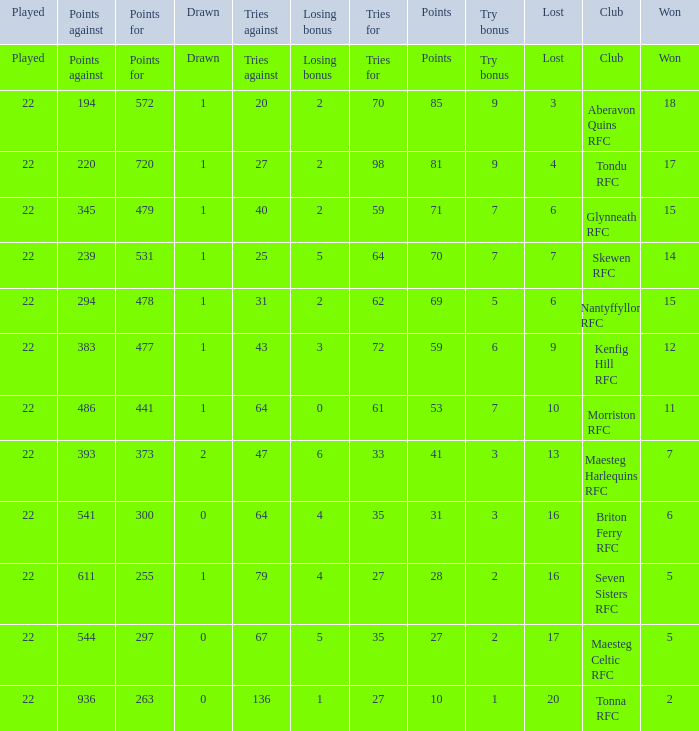What club got 239 points against? Skewen RFC. 